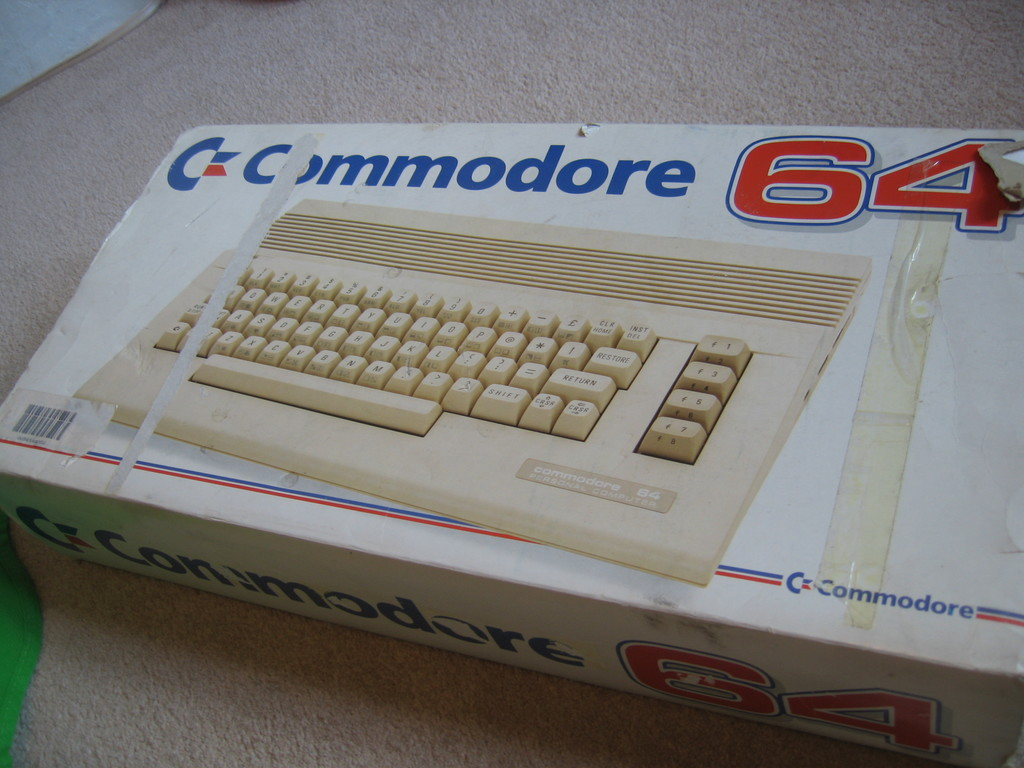Provide a one-sentence caption for the provided image.
Reference OCR token: &C, mmodore, 64, RETURN, scomeders, C=, Commodore a box with a keyboard picture on it that looks old and taped, brand name is Commodore 64. 